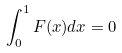Convert formula to latex. <formula><loc_0><loc_0><loc_500><loc_500>\int _ { 0 } ^ { 1 } F ( x ) d x = 0</formula> 